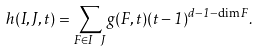Convert formula to latex. <formula><loc_0><loc_0><loc_500><loc_500>h ( I , J , t ) = \sum _ { F \in I \ J } g ( F , t ) ( t - 1 ) ^ { d - 1 - \dim F } .</formula> 